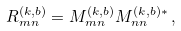Convert formula to latex. <formula><loc_0><loc_0><loc_500><loc_500>R _ { m n } ^ { ( k , b ) } = M _ { m n } ^ { ( k , b ) } M _ { n n } ^ { ( k , b ) * } \, ,</formula> 